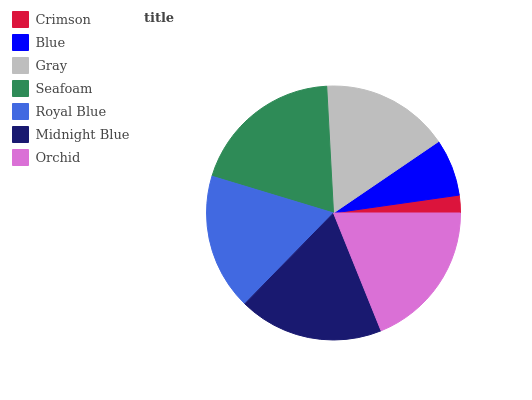Is Crimson the minimum?
Answer yes or no. Yes. Is Seafoam the maximum?
Answer yes or no. Yes. Is Blue the minimum?
Answer yes or no. No. Is Blue the maximum?
Answer yes or no. No. Is Blue greater than Crimson?
Answer yes or no. Yes. Is Crimson less than Blue?
Answer yes or no. Yes. Is Crimson greater than Blue?
Answer yes or no. No. Is Blue less than Crimson?
Answer yes or no. No. Is Royal Blue the high median?
Answer yes or no. Yes. Is Royal Blue the low median?
Answer yes or no. Yes. Is Crimson the high median?
Answer yes or no. No. Is Seafoam the low median?
Answer yes or no. No. 